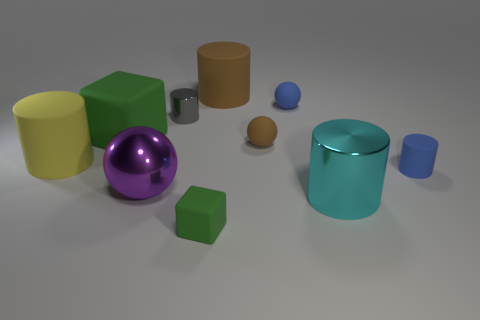Subtract all brown cylinders. How many cylinders are left? 4 Subtract all blue cylinders. How many cylinders are left? 4 Subtract all gray cylinders. Subtract all cyan balls. How many cylinders are left? 4 Subtract all spheres. How many objects are left? 7 Subtract all tiny blue matte balls. Subtract all metallic balls. How many objects are left? 8 Add 1 small gray metallic objects. How many small gray metallic objects are left? 2 Add 2 small cylinders. How many small cylinders exist? 4 Subtract 0 blue blocks. How many objects are left? 10 